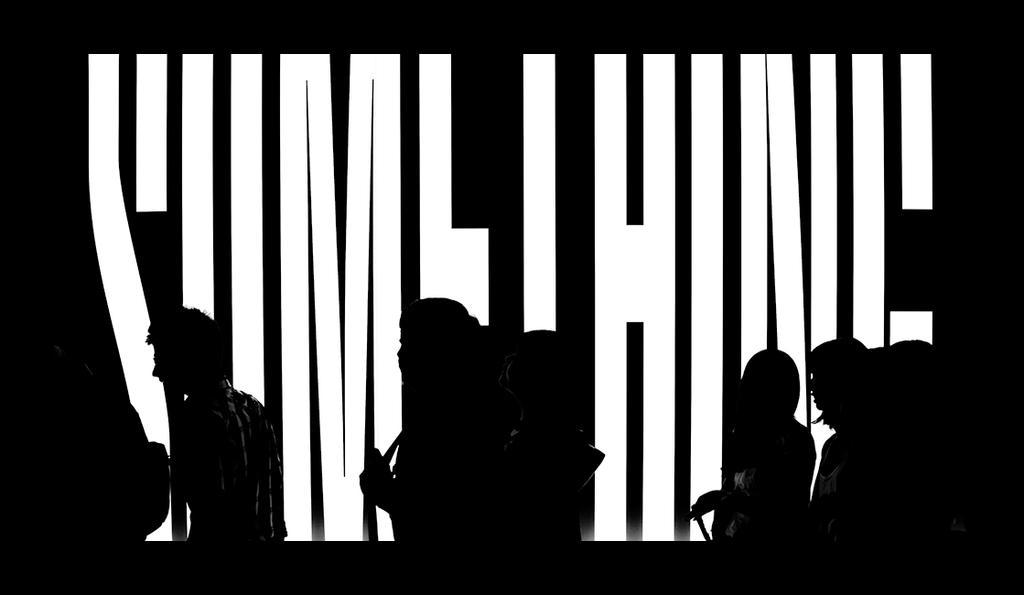Describe this image in one or two sentences. In the picture we can see group of persons walking and in the background there is black color screen and there are some letters in white color. 